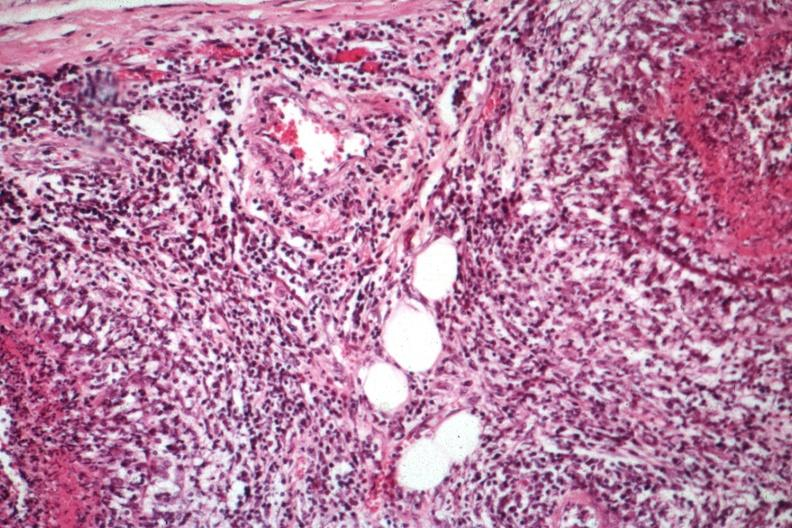what is present?
Answer the question using a single word or phrase. Testicle 